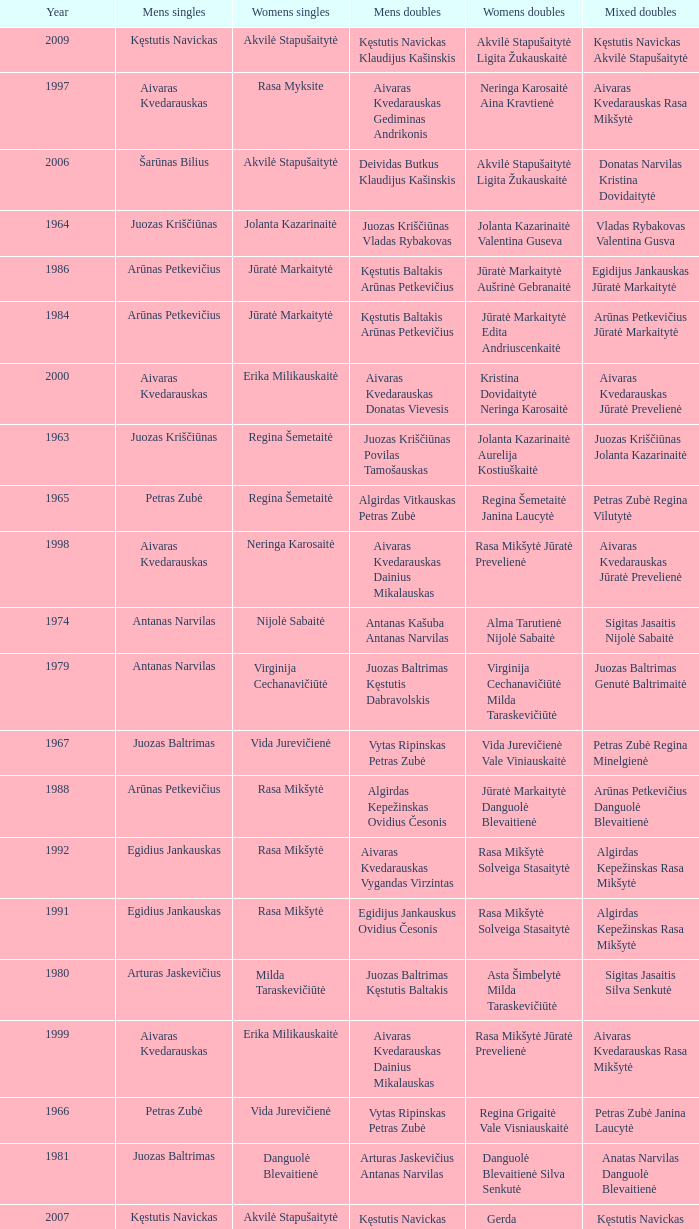What was the first year of the Lithuanian National Badminton Championships? 1963.0. 